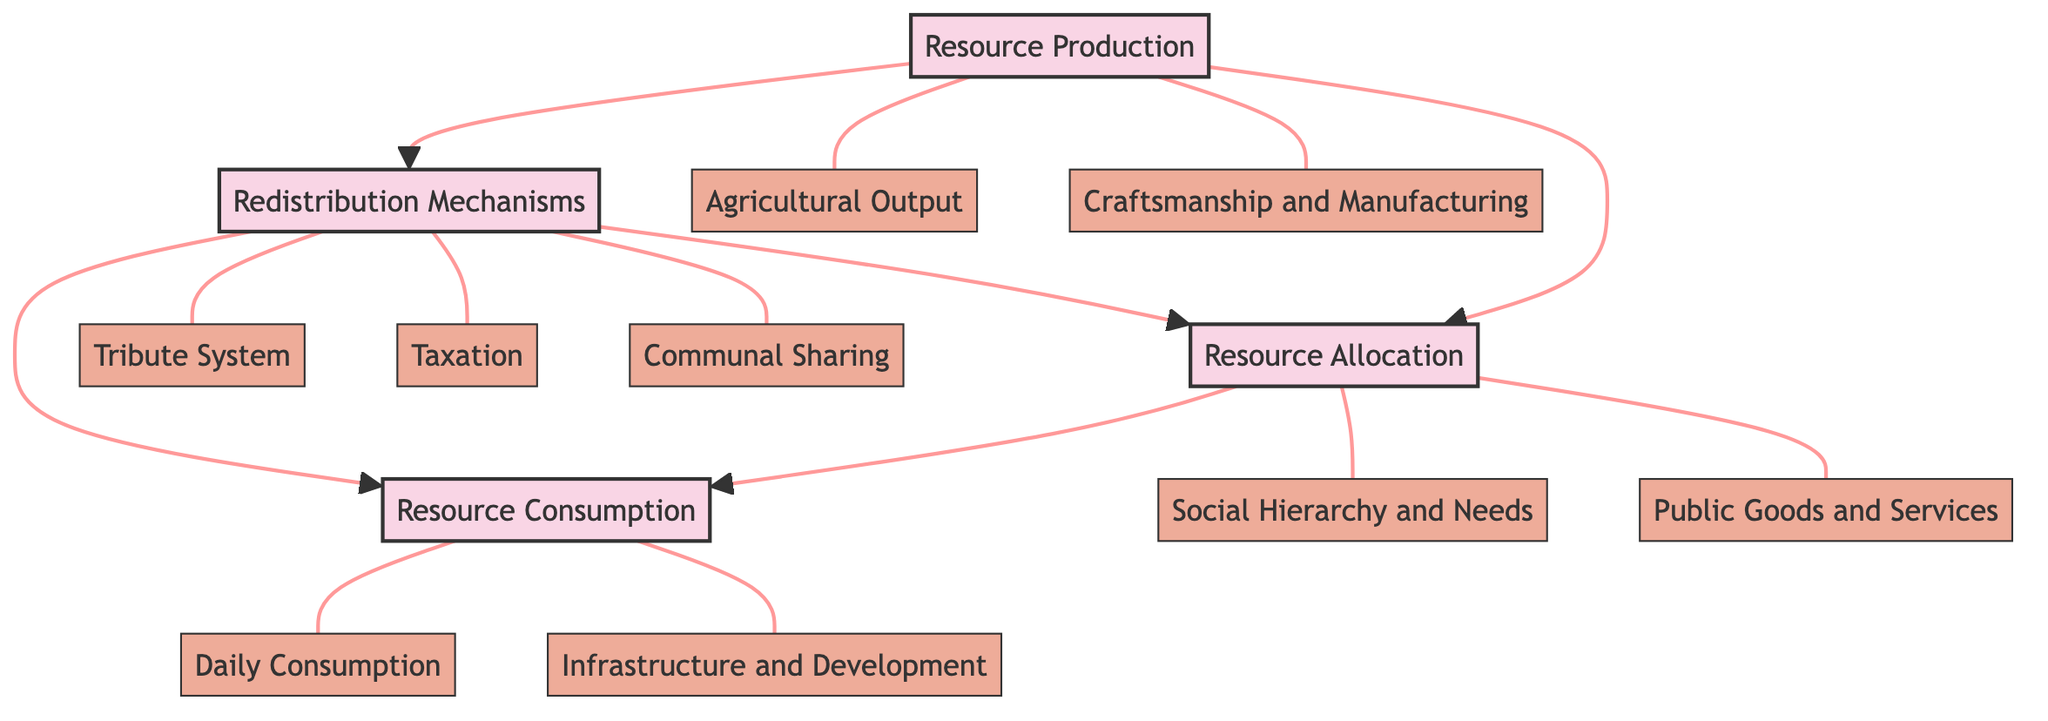What is the primary process of the diagram? The diagram indicates that the main process is "Resource Production," as it is the first node leading to both resource allocation and redistribution processes.
Answer: Resource Production How many subcategories fall under Resource Production? There are two subcategories under "Resource Production": "Agricultural Output" and "Craftsmanship and Manufacturing." This is determined by counting the connections that extend from the "Resource Production" node.
Answer: 2 What are the two main processes connected to Resource Allocation? The diagram shows that "Resource Allocation" connects to "Consumption" and is also linked with "Redistribution," indicating these two processes are the main outputs of resource allocation.
Answer: Consumption and Redistribution Which category addresses the needs related to social status? "Social Hierarchy and Needs" is the subcategory that directly relates to the distribution of resources based on social status within the diagram, as indicated by its direct connection to "Resource Allocation."
Answer: Social Hierarchy and Needs What is the relationship between Redistribution Mechanisms and Resource Allocation? "Redistribution Mechanisms" has a feedback loop connection to "Resource Allocation," suggesting that resources are not only distributed but can also influence how resources are allocated back to society.
Answer: Feedback loop How many types of Redistribution Mechanisms are illustrated in the diagram? The diagram illustrates three types of Redistribution Mechanisms: "Tribute System," "Taxation," and "Communal Sharing." This is based on the three subcategories branching from the "Redistribution Mechanisms" node.
Answer: 3 Which two processes lead to Resource Consumption? "Resource Allocation" and "Redistribution" are the two processes leading to "Resource Consumption," as indicated by their direct connections to the consumption node.
Answer: Resource Allocation and Redistribution Which subcategory directly supports public infrastructure? "Infrastructure and Development" is the subcategory that supports public infrastructure, positioned under the "Resource Consumption" process to indicate resource allocation toward building and maintaining infrastructure.
Answer: Infrastructure and Development What type of goods are classified under Public Goods and Services? "Public Goods and Services" encompasses resources provided for communal use like irrigation systems and public buildings, as indicated in the diagram.
Answer: Communal goods 